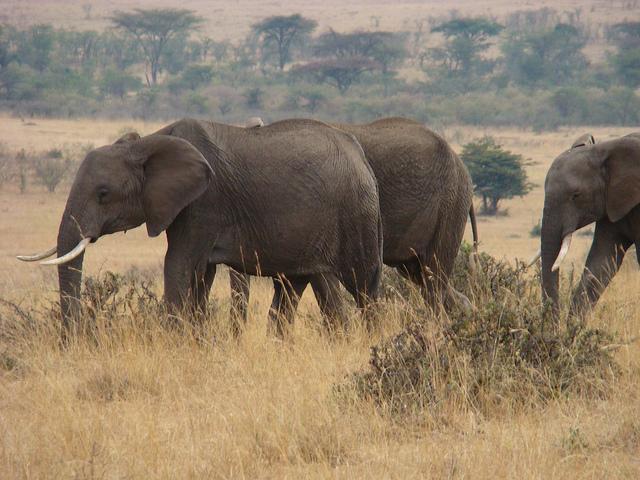How many animals are shown here?
Be succinct. 3. What type of animal are these?
Keep it brief. Elephants. What are the long white objects protruding from the elephants mouth?
Keep it brief. Tusks. 